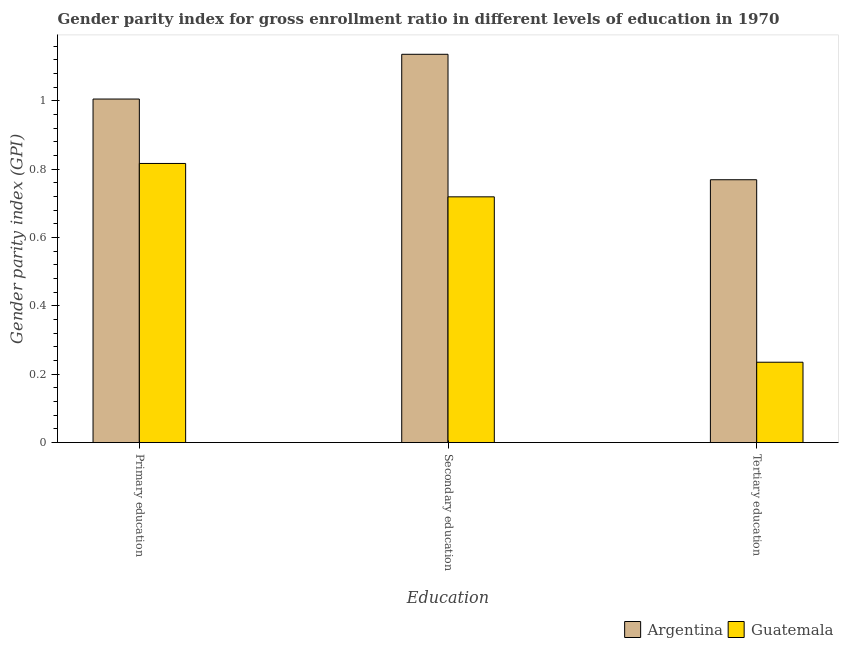How many groups of bars are there?
Your answer should be very brief. 3. Are the number of bars on each tick of the X-axis equal?
Your answer should be very brief. Yes. What is the label of the 1st group of bars from the left?
Offer a terse response. Primary education. What is the gender parity index in secondary education in Guatemala?
Provide a succinct answer. 0.72. Across all countries, what is the maximum gender parity index in tertiary education?
Offer a terse response. 0.77. Across all countries, what is the minimum gender parity index in secondary education?
Your answer should be very brief. 0.72. In which country was the gender parity index in secondary education minimum?
Your answer should be compact. Guatemala. What is the total gender parity index in tertiary education in the graph?
Make the answer very short. 1. What is the difference between the gender parity index in secondary education in Guatemala and that in Argentina?
Your answer should be compact. -0.42. What is the difference between the gender parity index in secondary education in Guatemala and the gender parity index in tertiary education in Argentina?
Offer a very short reply. -0.05. What is the average gender parity index in tertiary education per country?
Your answer should be very brief. 0.5. What is the difference between the gender parity index in tertiary education and gender parity index in primary education in Argentina?
Keep it short and to the point. -0.24. In how many countries, is the gender parity index in tertiary education greater than 0.48000000000000004 ?
Give a very brief answer. 1. What is the ratio of the gender parity index in primary education in Guatemala to that in Argentina?
Your answer should be compact. 0.81. What is the difference between the highest and the second highest gender parity index in primary education?
Your answer should be compact. 0.19. What is the difference between the highest and the lowest gender parity index in tertiary education?
Your response must be concise. 0.53. In how many countries, is the gender parity index in secondary education greater than the average gender parity index in secondary education taken over all countries?
Ensure brevity in your answer.  1. Is the sum of the gender parity index in primary education in Argentina and Guatemala greater than the maximum gender parity index in secondary education across all countries?
Provide a short and direct response. Yes. What does the 1st bar from the left in Primary education represents?
Provide a succinct answer. Argentina. What does the 2nd bar from the right in Primary education represents?
Your answer should be very brief. Argentina. Is it the case that in every country, the sum of the gender parity index in primary education and gender parity index in secondary education is greater than the gender parity index in tertiary education?
Keep it short and to the point. Yes. How many bars are there?
Offer a terse response. 6. Are all the bars in the graph horizontal?
Offer a very short reply. No. How many countries are there in the graph?
Offer a very short reply. 2. What is the difference between two consecutive major ticks on the Y-axis?
Keep it short and to the point. 0.2. Are the values on the major ticks of Y-axis written in scientific E-notation?
Provide a short and direct response. No. Does the graph contain grids?
Your response must be concise. No. Where does the legend appear in the graph?
Provide a succinct answer. Bottom right. How many legend labels are there?
Your response must be concise. 2. How are the legend labels stacked?
Keep it short and to the point. Horizontal. What is the title of the graph?
Give a very brief answer. Gender parity index for gross enrollment ratio in different levels of education in 1970. Does "High income" appear as one of the legend labels in the graph?
Ensure brevity in your answer.  No. What is the label or title of the X-axis?
Keep it short and to the point. Education. What is the label or title of the Y-axis?
Your answer should be very brief. Gender parity index (GPI). What is the Gender parity index (GPI) in Argentina in Primary education?
Provide a succinct answer. 1.01. What is the Gender parity index (GPI) in Guatemala in Primary education?
Ensure brevity in your answer.  0.82. What is the Gender parity index (GPI) in Argentina in Secondary education?
Your answer should be compact. 1.14. What is the Gender parity index (GPI) of Guatemala in Secondary education?
Give a very brief answer. 0.72. What is the Gender parity index (GPI) in Argentina in Tertiary education?
Your response must be concise. 0.77. What is the Gender parity index (GPI) of Guatemala in Tertiary education?
Give a very brief answer. 0.24. Across all Education, what is the maximum Gender parity index (GPI) of Argentina?
Provide a short and direct response. 1.14. Across all Education, what is the maximum Gender parity index (GPI) in Guatemala?
Offer a terse response. 0.82. Across all Education, what is the minimum Gender parity index (GPI) of Argentina?
Offer a terse response. 0.77. Across all Education, what is the minimum Gender parity index (GPI) of Guatemala?
Your answer should be compact. 0.24. What is the total Gender parity index (GPI) of Argentina in the graph?
Make the answer very short. 2.91. What is the total Gender parity index (GPI) in Guatemala in the graph?
Offer a very short reply. 1.77. What is the difference between the Gender parity index (GPI) of Argentina in Primary education and that in Secondary education?
Give a very brief answer. -0.13. What is the difference between the Gender parity index (GPI) in Guatemala in Primary education and that in Secondary education?
Provide a short and direct response. 0.1. What is the difference between the Gender parity index (GPI) in Argentina in Primary education and that in Tertiary education?
Keep it short and to the point. 0.24. What is the difference between the Gender parity index (GPI) of Guatemala in Primary education and that in Tertiary education?
Offer a terse response. 0.58. What is the difference between the Gender parity index (GPI) in Argentina in Secondary education and that in Tertiary education?
Keep it short and to the point. 0.37. What is the difference between the Gender parity index (GPI) of Guatemala in Secondary education and that in Tertiary education?
Provide a succinct answer. 0.48. What is the difference between the Gender parity index (GPI) in Argentina in Primary education and the Gender parity index (GPI) in Guatemala in Secondary education?
Your response must be concise. 0.29. What is the difference between the Gender parity index (GPI) in Argentina in Primary education and the Gender parity index (GPI) in Guatemala in Tertiary education?
Your answer should be compact. 0.77. What is the difference between the Gender parity index (GPI) of Argentina in Secondary education and the Gender parity index (GPI) of Guatemala in Tertiary education?
Offer a terse response. 0.9. What is the average Gender parity index (GPI) in Argentina per Education?
Your answer should be compact. 0.97. What is the average Gender parity index (GPI) of Guatemala per Education?
Your answer should be compact. 0.59. What is the difference between the Gender parity index (GPI) of Argentina and Gender parity index (GPI) of Guatemala in Primary education?
Your response must be concise. 0.19. What is the difference between the Gender parity index (GPI) of Argentina and Gender parity index (GPI) of Guatemala in Secondary education?
Your answer should be very brief. 0.42. What is the difference between the Gender parity index (GPI) in Argentina and Gender parity index (GPI) in Guatemala in Tertiary education?
Your answer should be compact. 0.53. What is the ratio of the Gender parity index (GPI) in Argentina in Primary education to that in Secondary education?
Your answer should be compact. 0.88. What is the ratio of the Gender parity index (GPI) of Guatemala in Primary education to that in Secondary education?
Give a very brief answer. 1.14. What is the ratio of the Gender parity index (GPI) of Argentina in Primary education to that in Tertiary education?
Keep it short and to the point. 1.31. What is the ratio of the Gender parity index (GPI) of Guatemala in Primary education to that in Tertiary education?
Offer a very short reply. 3.47. What is the ratio of the Gender parity index (GPI) in Argentina in Secondary education to that in Tertiary education?
Give a very brief answer. 1.48. What is the ratio of the Gender parity index (GPI) in Guatemala in Secondary education to that in Tertiary education?
Provide a succinct answer. 3.06. What is the difference between the highest and the second highest Gender parity index (GPI) of Argentina?
Provide a short and direct response. 0.13. What is the difference between the highest and the second highest Gender parity index (GPI) of Guatemala?
Offer a terse response. 0.1. What is the difference between the highest and the lowest Gender parity index (GPI) of Argentina?
Offer a terse response. 0.37. What is the difference between the highest and the lowest Gender parity index (GPI) in Guatemala?
Offer a terse response. 0.58. 